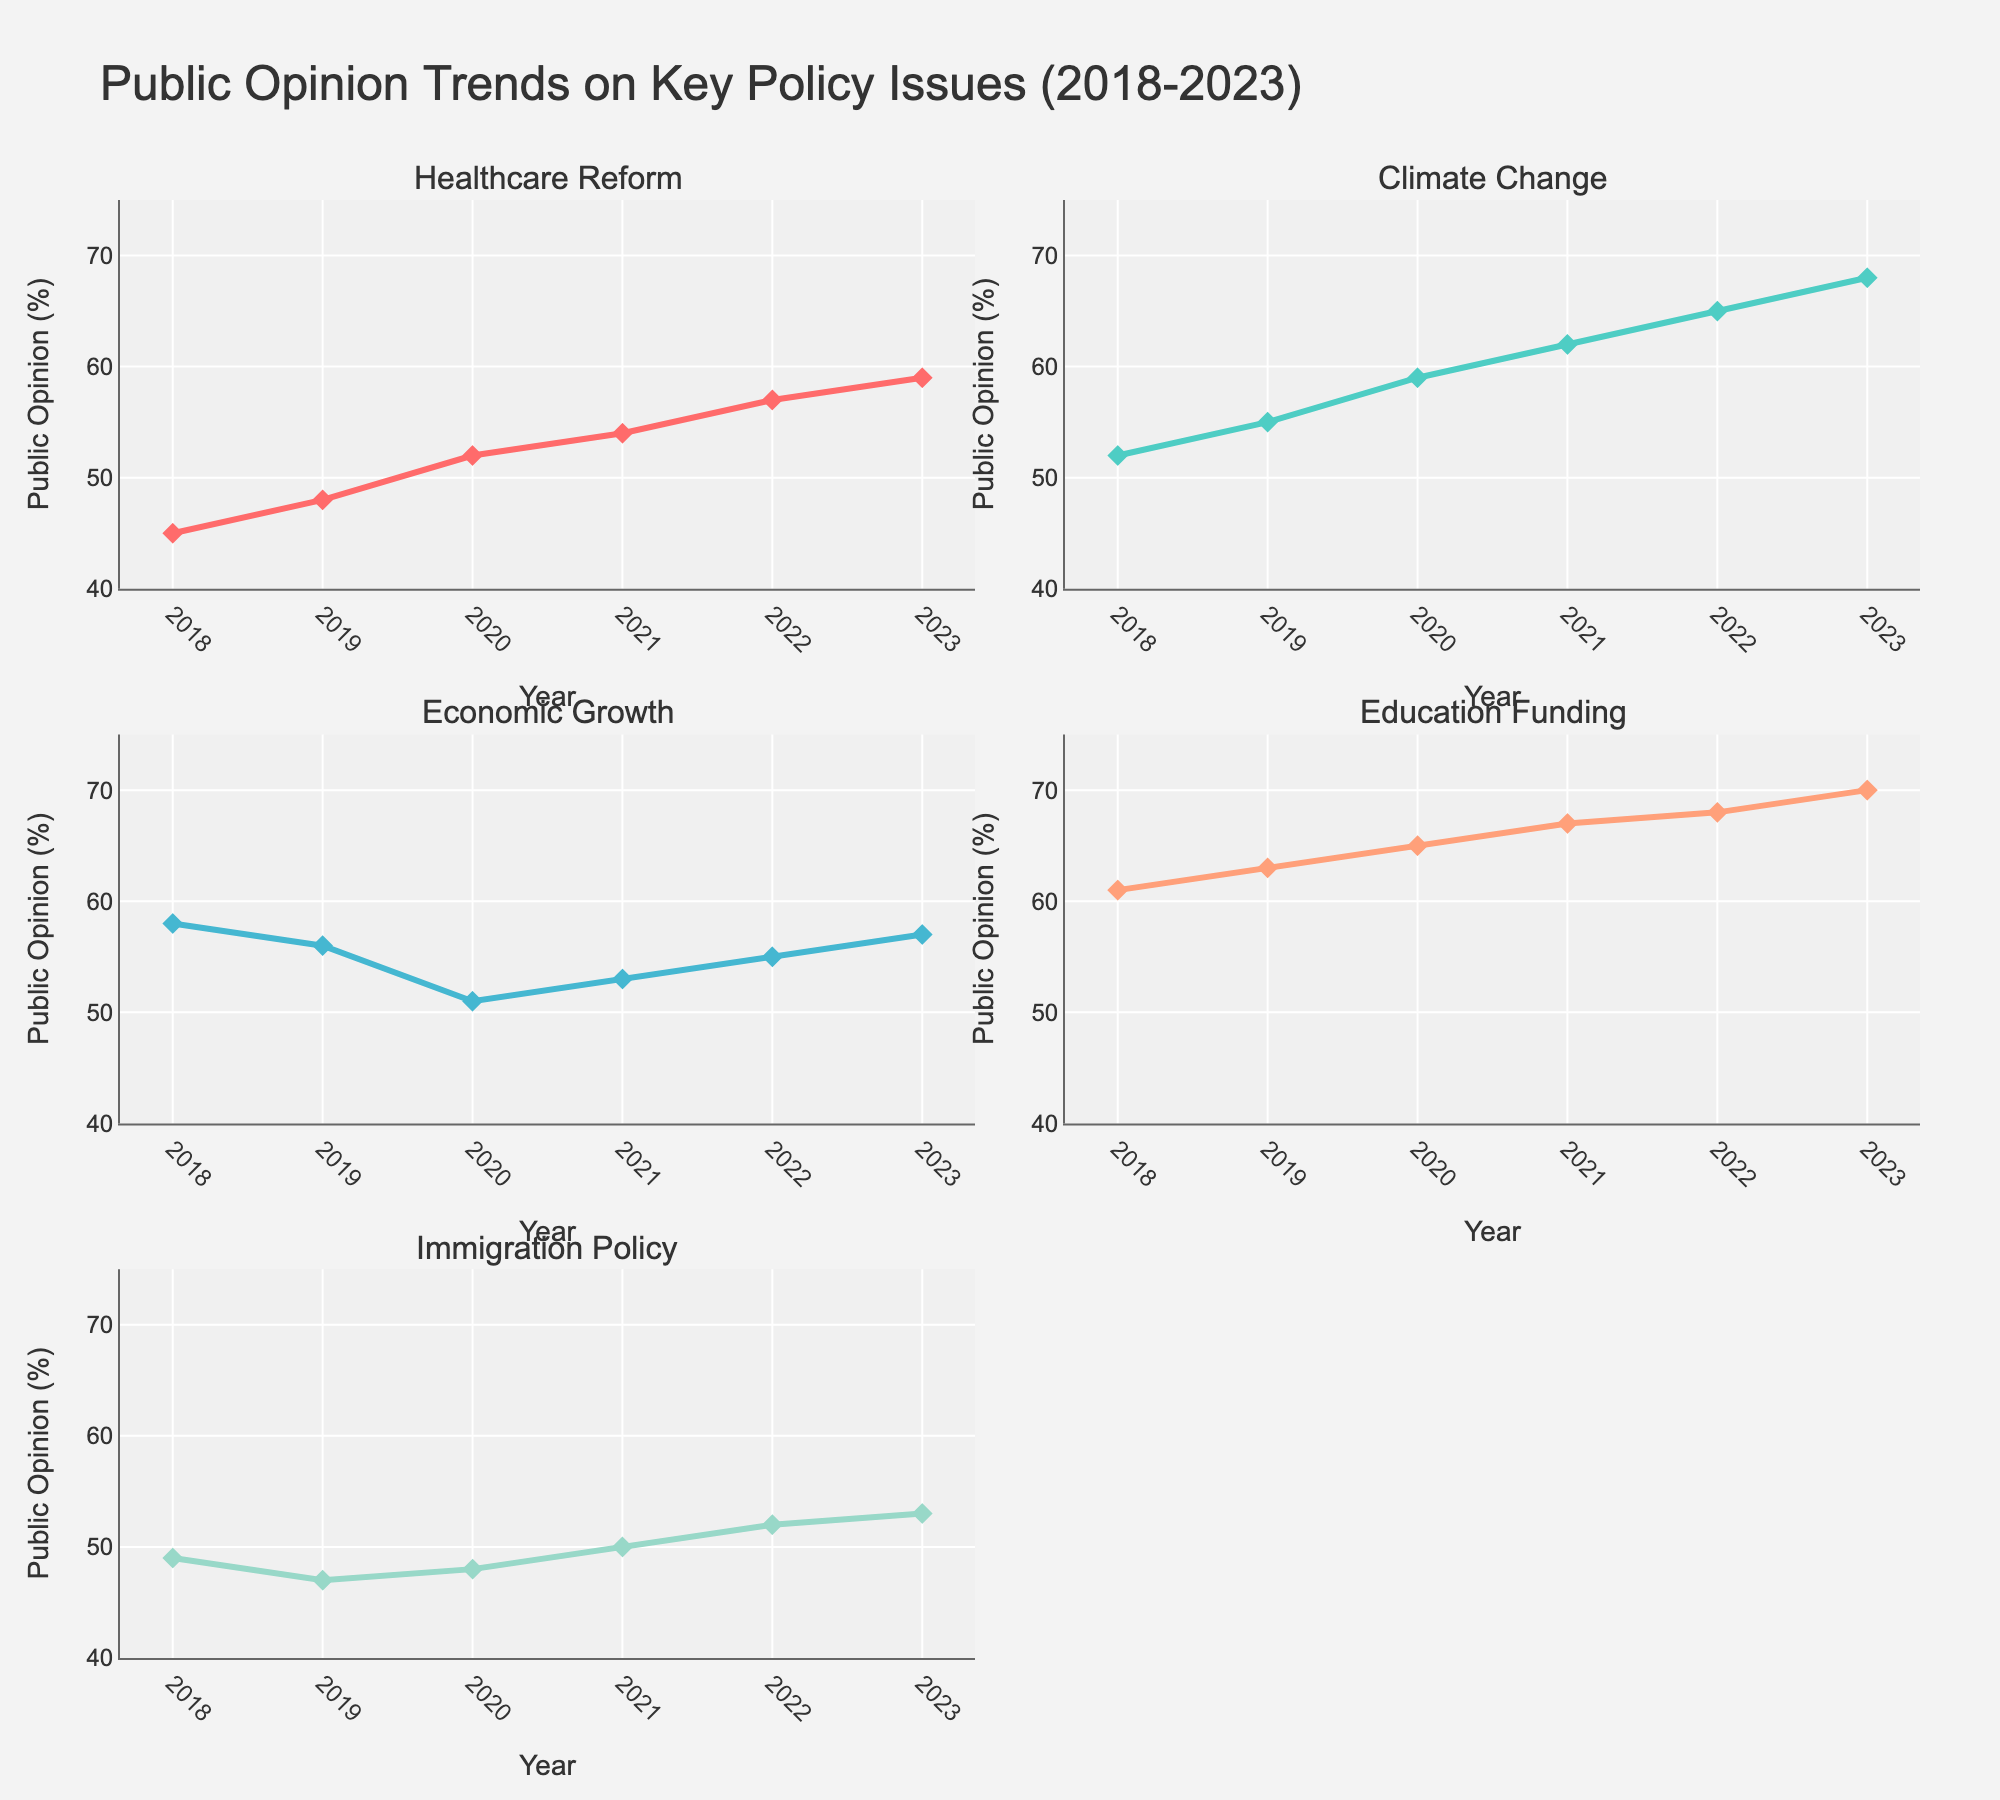What's the title of the figure? The title is located at the top of the figure and clearly states the overall theme of the data being presented.
Answer: Public Opinion Trends on Key Policy Issues (2018-2023) How many years of data are shown in each subplot? By examining the x-axis of each subplot, you can see it ranges from 2018 to 2023, which includes a total of 6 years of data.
Answer: 6 Which policy issue saw the largest increase in public opinion from 2018 to 2023? To determine this, look at the final percentage in 2023 and subtract it from the initial percentage in 2018 for each policy issue. Compare the differences to find the largest increase.
Answer: Climate Change What was the public opinion on Education Funding in 2019 versus 2023? Find and compare the data points for Education Funding in the subplots for the years 2019 and 2023.
Answer: 63% in 2019 and 70% in 2023 Is there any policy issue that shows a decrease in public opinion between two consecutive years? Check each subplot for any downward trend lines between any two consecutive years. For example, Economic Growth shows a decline from 2018 to 2019.
Answer: Economic Growth from 2018 to 2019 What is the average public opinion across all years for Healthcare Reform? Sum up the public opinion percentages for Healthcare Reform from 2018 to 2023 and divide by the number of years, which is 6. (45 + 48 + 52 + 54 + 57 + 59) / 6 = 52.5
Answer: 52.5 Which two policy issues have the most similar public opinion trends over the years? Visually compare the line plots and identify which two have the closest trends in terms of their shapes and data points.
Answer: Education Funding and Healthcare Reform How much did the public opinion of Immigration Policy change from 2018 to 2023? Subtract the public opinion percentage of Immigration Policy in 2018 from that in 2023: 53% - 49% = 4%.
Answer: 4% In which year did Climate Change see the highest public opinion percentage? Look at the data points for Climate Change and identify the year where the percentage was the highest.
Answer: 2023 If you average the public opinions of all policy issues for the year 2020, what would the result be? Add up the public opinion percentages for all policy issues in 2020 and divide by the number of issues, which is 5. (52 + 59 + 51 + 65 + 48) / 5 = 55
Answer: 55 